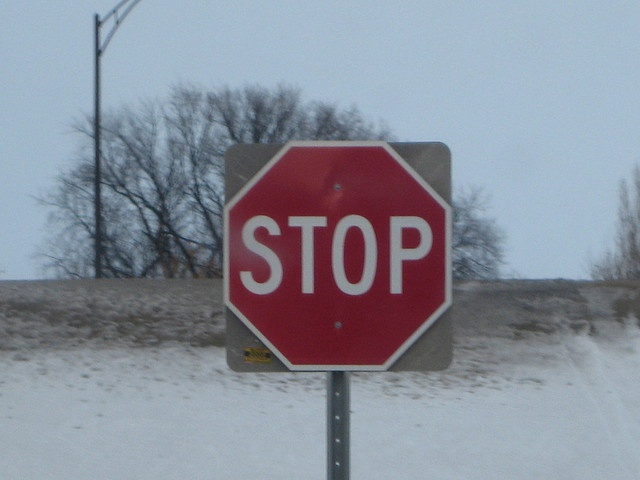Describe the objects in this image and their specific colors. I can see a stop sign in lightblue, maroon, gray, and brown tones in this image. 